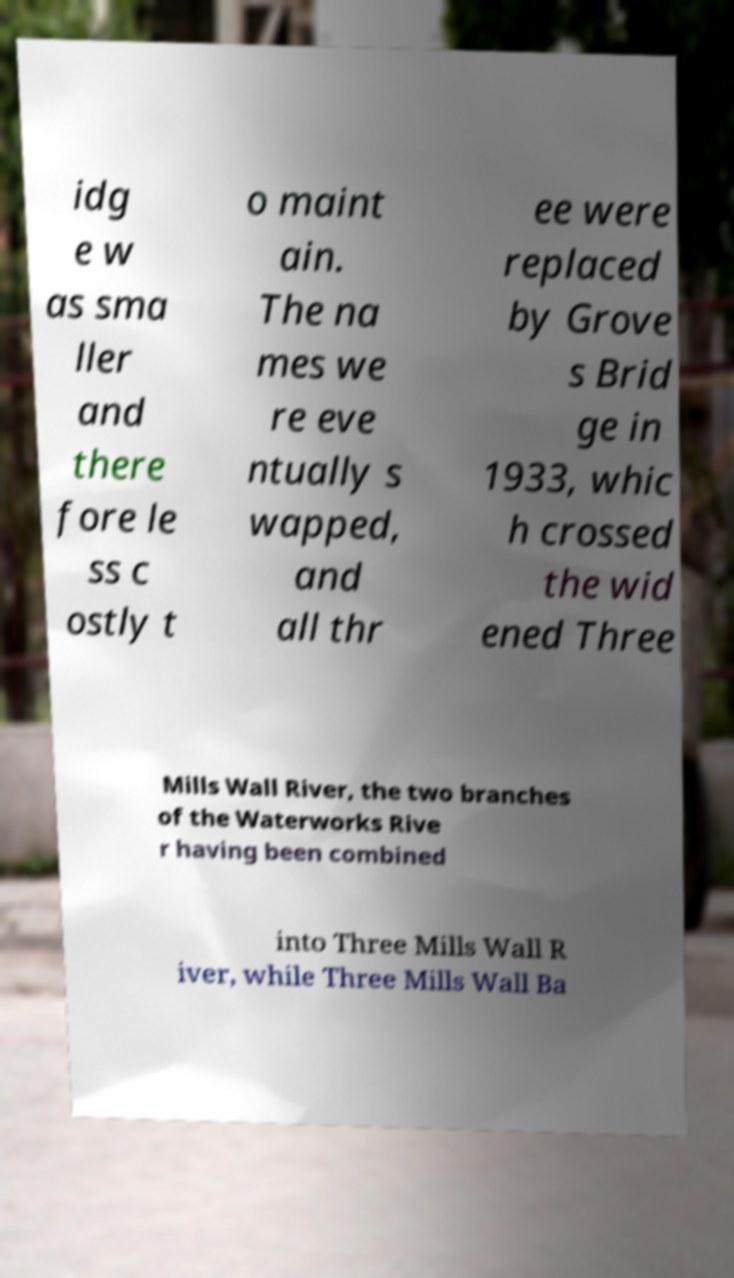Please identify and transcribe the text found in this image. idg e w as sma ller and there fore le ss c ostly t o maint ain. The na mes we re eve ntually s wapped, and all thr ee were replaced by Grove s Brid ge in 1933, whic h crossed the wid ened Three Mills Wall River, the two branches of the Waterworks Rive r having been combined into Three Mills Wall R iver, while Three Mills Wall Ba 